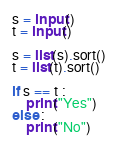Convert code to text. <code><loc_0><loc_0><loc_500><loc_500><_Python_>s = input()
t = input()

s = list(s).sort()
t = list(t).sort()

if s == t :
    print("Yes")
else :
    print("No")</code> 